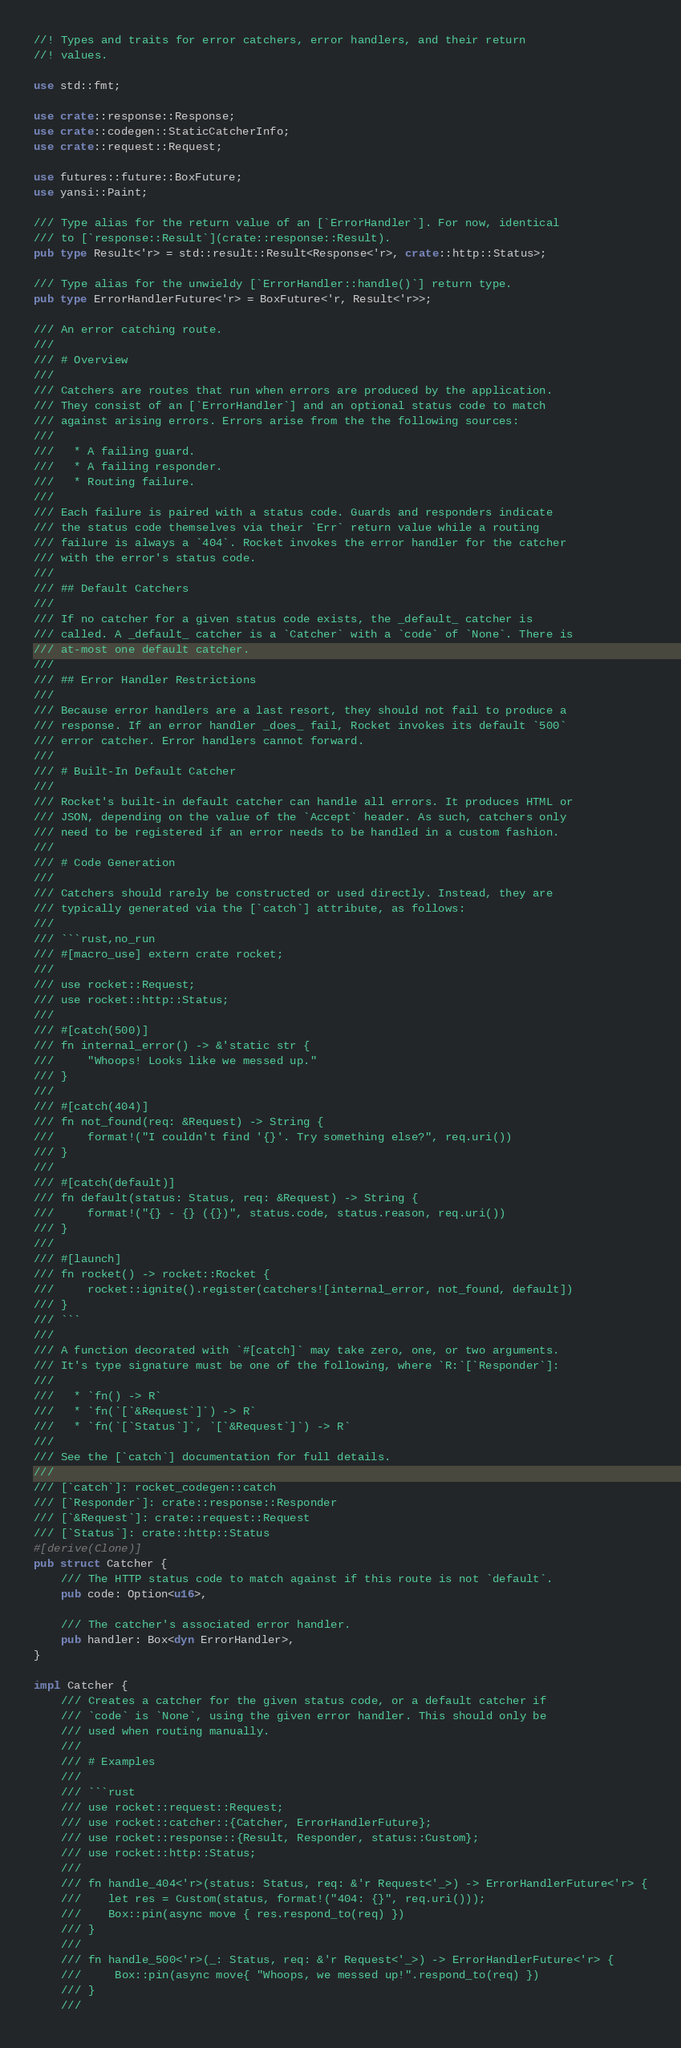Convert code to text. <code><loc_0><loc_0><loc_500><loc_500><_Rust_>//! Types and traits for error catchers, error handlers, and their return
//! values.

use std::fmt;

use crate::response::Response;
use crate::codegen::StaticCatcherInfo;
use crate::request::Request;

use futures::future::BoxFuture;
use yansi::Paint;

/// Type alias for the return value of an [`ErrorHandler`]. For now, identical
/// to [`response::Result`](crate::response::Result).
pub type Result<'r> = std::result::Result<Response<'r>, crate::http::Status>;

/// Type alias for the unwieldy [`ErrorHandler::handle()`] return type.
pub type ErrorHandlerFuture<'r> = BoxFuture<'r, Result<'r>>;

/// An error catching route.
///
/// # Overview
///
/// Catchers are routes that run when errors are produced by the application.
/// They consist of an [`ErrorHandler`] and an optional status code to match
/// against arising errors. Errors arise from the the following sources:
///
///   * A failing guard.
///   * A failing responder.
///   * Routing failure.
///
/// Each failure is paired with a status code. Guards and responders indicate
/// the status code themselves via their `Err` return value while a routing
/// failure is always a `404`. Rocket invokes the error handler for the catcher
/// with the error's status code.
///
/// ## Default Catchers
///
/// If no catcher for a given status code exists, the _default_ catcher is
/// called. A _default_ catcher is a `Catcher` with a `code` of `None`. There is
/// at-most one default catcher.
///
/// ## Error Handler Restrictions
///
/// Because error handlers are a last resort, they should not fail to produce a
/// response. If an error handler _does_ fail, Rocket invokes its default `500`
/// error catcher. Error handlers cannot forward.
///
/// # Built-In Default Catcher
///
/// Rocket's built-in default catcher can handle all errors. It produces HTML or
/// JSON, depending on the value of the `Accept` header. As such, catchers only
/// need to be registered if an error needs to be handled in a custom fashion.
///
/// # Code Generation
///
/// Catchers should rarely be constructed or used directly. Instead, they are
/// typically generated via the [`catch`] attribute, as follows:
///
/// ```rust,no_run
/// #[macro_use] extern crate rocket;
///
/// use rocket::Request;
/// use rocket::http::Status;
///
/// #[catch(500)]
/// fn internal_error() -> &'static str {
///     "Whoops! Looks like we messed up."
/// }
///
/// #[catch(404)]
/// fn not_found(req: &Request) -> String {
///     format!("I couldn't find '{}'. Try something else?", req.uri())
/// }
///
/// #[catch(default)]
/// fn default(status: Status, req: &Request) -> String {
///     format!("{} - {} ({})", status.code, status.reason, req.uri())
/// }
///
/// #[launch]
/// fn rocket() -> rocket::Rocket {
///     rocket::ignite().register(catchers![internal_error, not_found, default])
/// }
/// ```
///
/// A function decorated with `#[catch]` may take zero, one, or two arguments.
/// It's type signature must be one of the following, where `R:`[`Responder`]:
///
///   * `fn() -> R`
///   * `fn(`[`&Request`]`) -> R`
///   * `fn(`[`Status`]`, `[`&Request`]`) -> R`
///
/// See the [`catch`] documentation for full details.
///
/// [`catch`]: rocket_codegen::catch
/// [`Responder`]: crate::response::Responder
/// [`&Request`]: crate::request::Request
/// [`Status`]: crate::http::Status
#[derive(Clone)]
pub struct Catcher {
    /// The HTTP status code to match against if this route is not `default`.
    pub code: Option<u16>,

    /// The catcher's associated error handler.
    pub handler: Box<dyn ErrorHandler>,
}

impl Catcher {
    /// Creates a catcher for the given status code, or a default catcher if
    /// `code` is `None`, using the given error handler. This should only be
    /// used when routing manually.
    ///
    /// # Examples
    ///
    /// ```rust
    /// use rocket::request::Request;
    /// use rocket::catcher::{Catcher, ErrorHandlerFuture};
    /// use rocket::response::{Result, Responder, status::Custom};
    /// use rocket::http::Status;
    ///
    /// fn handle_404<'r>(status: Status, req: &'r Request<'_>) -> ErrorHandlerFuture<'r> {
    ///    let res = Custom(status, format!("404: {}", req.uri()));
    ///    Box::pin(async move { res.respond_to(req) })
    /// }
    ///
    /// fn handle_500<'r>(_: Status, req: &'r Request<'_>) -> ErrorHandlerFuture<'r> {
    ///     Box::pin(async move{ "Whoops, we messed up!".respond_to(req) })
    /// }
    ///</code> 